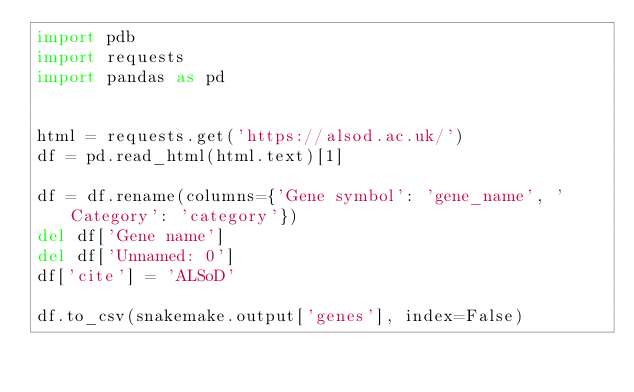Convert code to text. <code><loc_0><loc_0><loc_500><loc_500><_Python_>import pdb
import requests
import pandas as pd


html = requests.get('https://alsod.ac.uk/')
df = pd.read_html(html.text)[1]

df = df.rename(columns={'Gene symbol': 'gene_name', 'Category': 'category'})
del df['Gene name']
del df['Unnamed: 0']
df['cite'] = 'ALSoD'

df.to_csv(snakemake.output['genes'], index=False)
</code> 